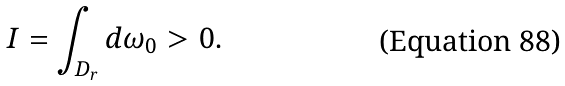Convert formula to latex. <formula><loc_0><loc_0><loc_500><loc_500>I = \int _ { D _ { r } } d \omega _ { 0 } > 0 .</formula> 